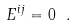Convert formula to latex. <formula><loc_0><loc_0><loc_500><loc_500>E ^ { i j } = 0 \ .</formula> 